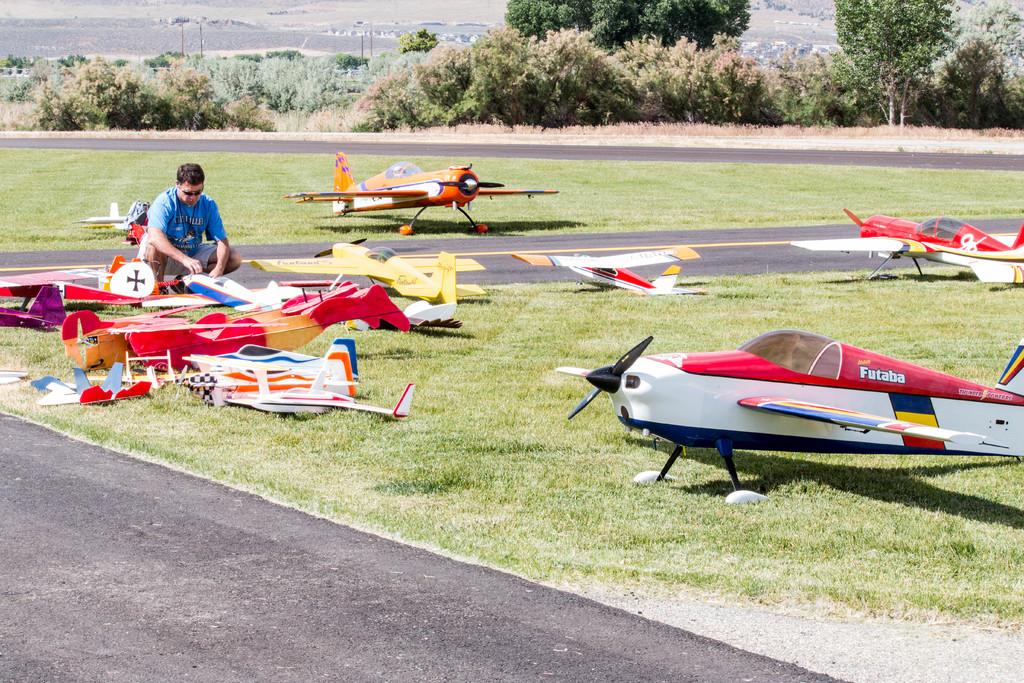What is the brand name on the plane?
Provide a short and direct response. Futaba. 